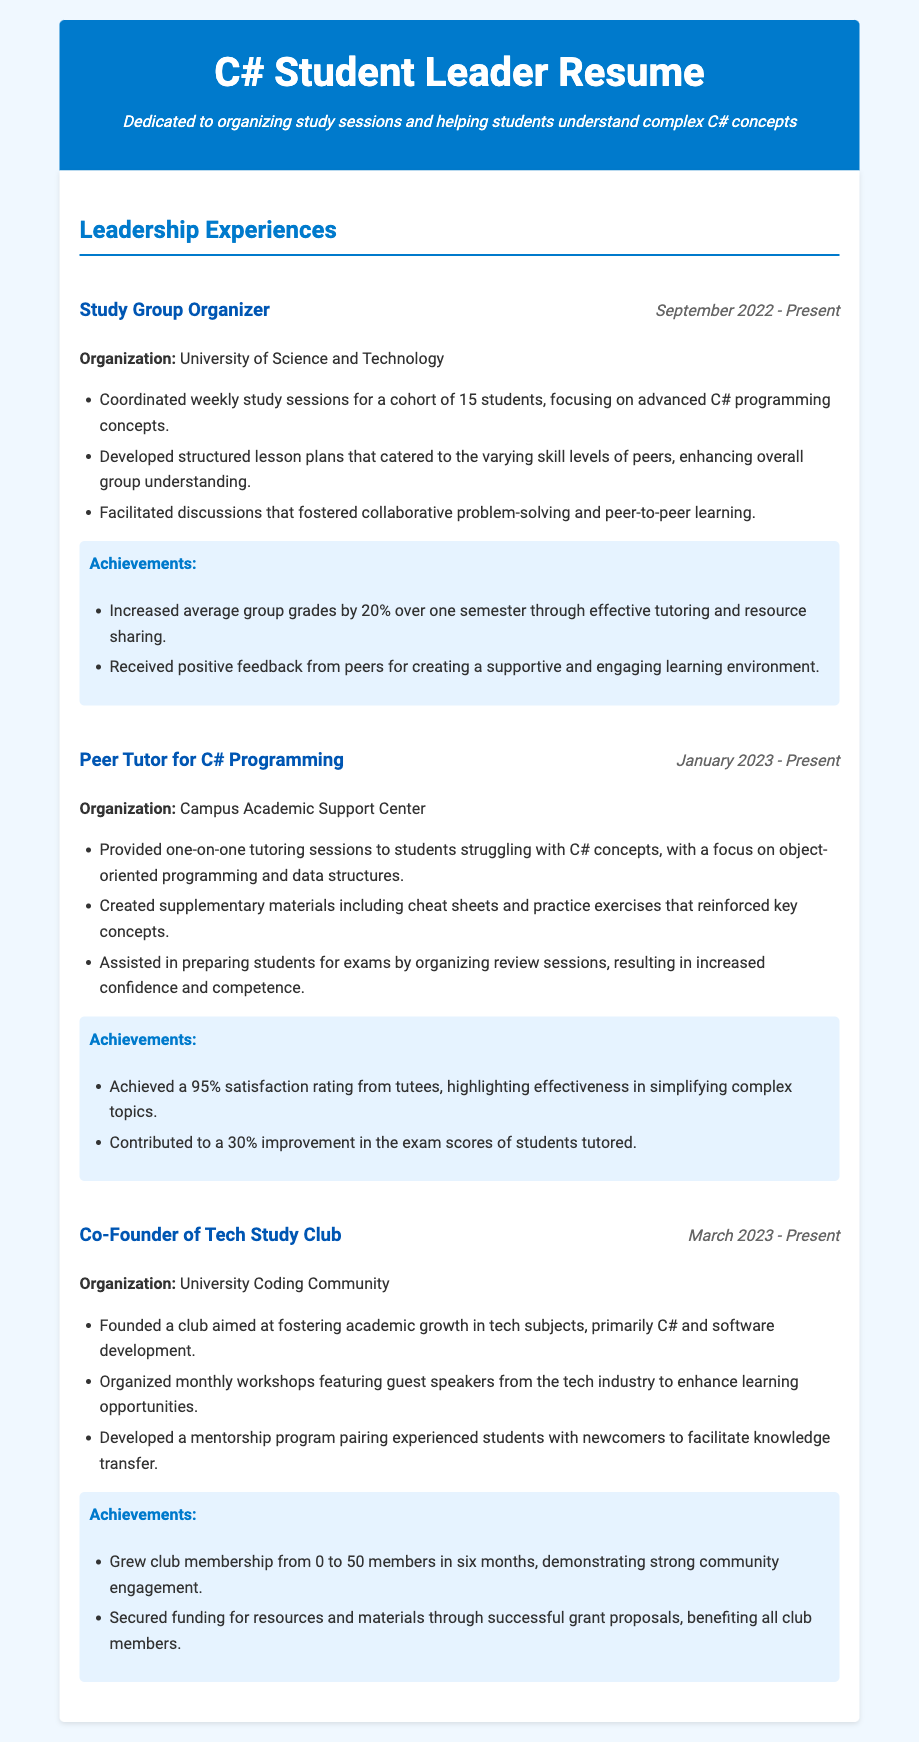What is the title of the document? The title of the document, as presented in the header, is "C# Student Leader Resume."
Answer: C# Student Leader Resume Who organized study sessions for students? The document highlights that a "Study Group Organizer" coordinated the weekly study sessions.
Answer: Study Group Organizer What organization is associated with the Study Group Organizer role? The organization listed for the Study Group Organizer role is "University of Science and Technology."
Answer: University of Science and Technology In which month did the Peer Tutor role begin? The document states that the Peer Tutor for C# Programming started in January 2023.
Answer: January 2023 What was the average improvement in group grades attributed to the Study Group Organizer? The average improvement in group grades is mentioned as a 20% increase over one semester.
Answer: 20% What is one of the key focuses of the Peer Tutor's sessions? The focus of the Peer Tutor's sessions is highlighted as "object-oriented programming and data structures."
Answer: object-oriented programming and data structures How many members were in the Tech Study Club after six months? The document states that the Tech Study Club grew its membership from 0 to 50 members in six months.
Answer: 50 members What rating did tutees give to the Peer Tutor? The satisfaction rating achieved by the Peer Tutor from tutees is 95%.
Answer: 95% What type of program was developed by the Co-Founder of Tech Study Club? The Co-Founder developed a mentorship program to facilitate knowledge transfer.
Answer: mentorship program 